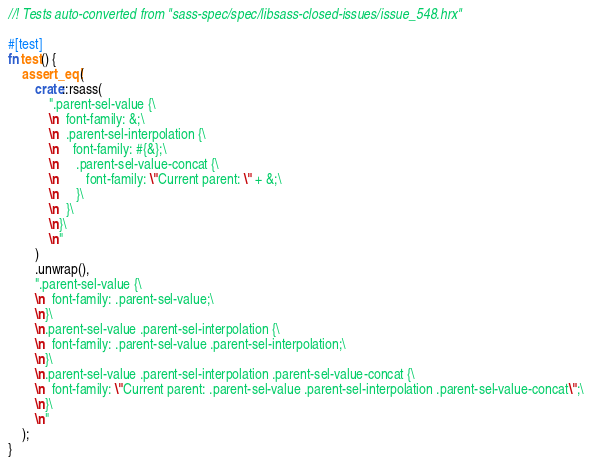<code> <loc_0><loc_0><loc_500><loc_500><_Rust_>//! Tests auto-converted from "sass-spec/spec/libsass-closed-issues/issue_548.hrx"

#[test]
fn test() {
    assert_eq!(
        crate::rsass(
            ".parent-sel-value {\
            \n  font-family: &;\
            \n  .parent-sel-interpolation {\
            \n    font-family: #{&};\
            \n     .parent-sel-value-concat {\
            \n        font-family: \"Current parent: \" + &;\
            \n     }\
            \n  }\
            \n}\
            \n"
        )
        .unwrap(),
        ".parent-sel-value {\
        \n  font-family: .parent-sel-value;\
        \n}\
        \n.parent-sel-value .parent-sel-interpolation {\
        \n  font-family: .parent-sel-value .parent-sel-interpolation;\
        \n}\
        \n.parent-sel-value .parent-sel-interpolation .parent-sel-value-concat {\
        \n  font-family: \"Current parent: .parent-sel-value .parent-sel-interpolation .parent-sel-value-concat\";\
        \n}\
        \n"
    );
}
</code> 